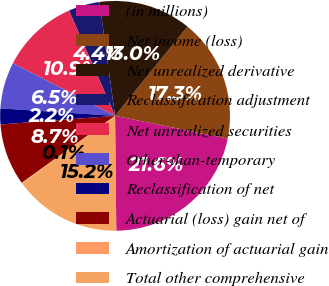<chart> <loc_0><loc_0><loc_500><loc_500><pie_chart><fcel>(in millions)<fcel>Net income (loss)<fcel>Net unrealized derivative<fcel>Reclassification adjustment<fcel>Net unrealized securities<fcel>Other-than-temporary<fcel>Reclassification of net<fcel>Actuarial (loss) gain net of<fcel>Amortization of actuarial gain<fcel>Total other comprehensive<nl><fcel>21.65%<fcel>17.34%<fcel>13.02%<fcel>4.39%<fcel>10.86%<fcel>6.55%<fcel>2.23%<fcel>8.71%<fcel>0.08%<fcel>15.18%<nl></chart> 